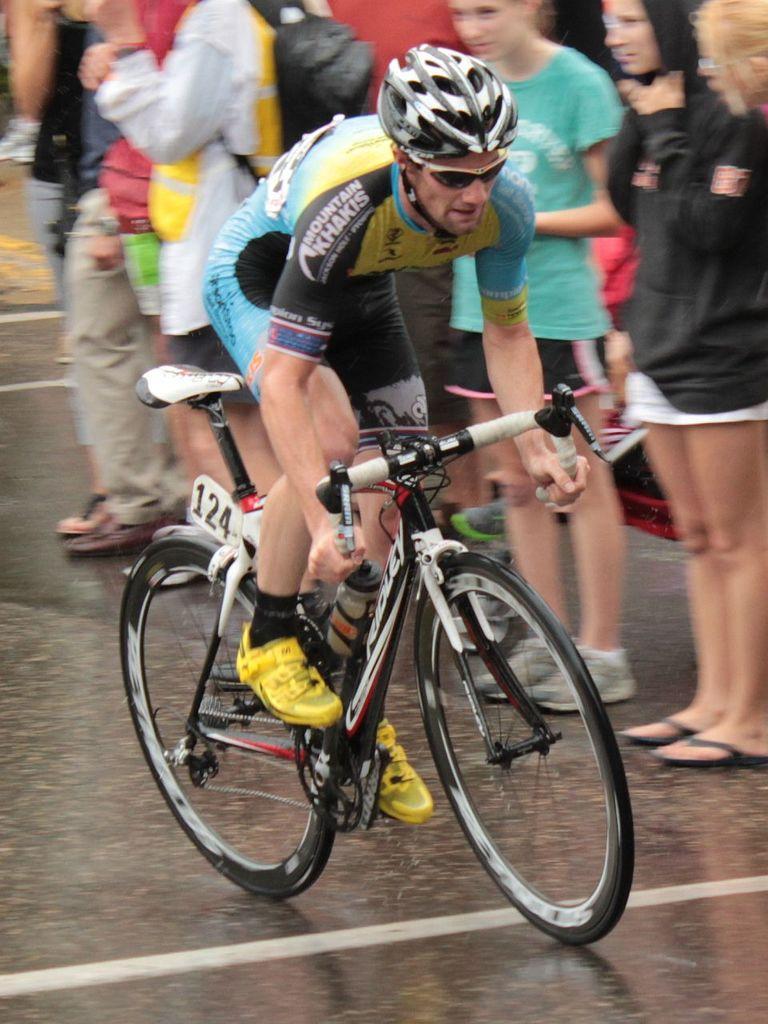Can you describe this image briefly? In this picture we have a man riding bicycle and in the back ground there are group of people standing in the road. 